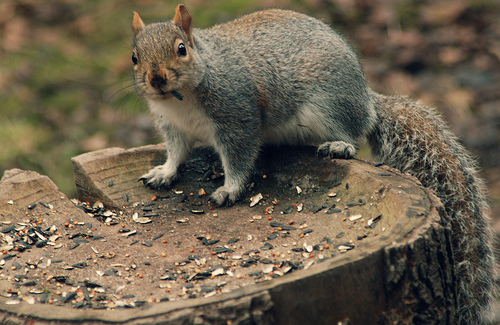<image>
Can you confirm if the squirrel is on the sunflower seed? Yes. Looking at the image, I can see the squirrel is positioned on top of the sunflower seed, with the sunflower seed providing support. 